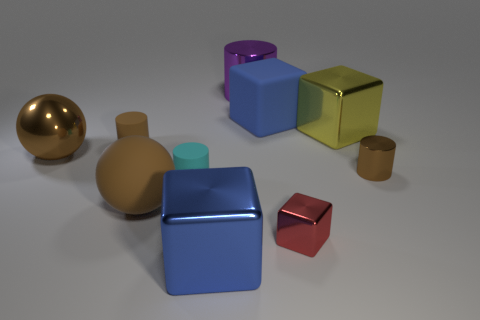Are the tiny cyan cylinder and the sphere behind the big brown matte object made of the same material?
Provide a short and direct response. No. How many objects are purple shiny objects or big purple metallic balls?
Provide a succinct answer. 1. Are any large spheres visible?
Ensure brevity in your answer.  Yes. What is the shape of the tiny object that is in front of the large brown thing that is in front of the large brown metal ball?
Your response must be concise. Cube. How many things are either small cylinders on the left side of the big yellow object or things in front of the small block?
Ensure brevity in your answer.  3. What is the material of the red cube that is the same size as the cyan object?
Your response must be concise. Metal. What is the color of the large metallic cylinder?
Offer a terse response. Purple. What is the material of the large cube that is left of the red shiny block and behind the brown matte cylinder?
Your answer should be compact. Rubber. There is a big blue object on the right side of the large blue cube that is to the left of the large purple metallic thing; is there a big blue cube in front of it?
Provide a succinct answer. Yes. There is a matte cylinder that is the same color as the big rubber sphere; what is its size?
Ensure brevity in your answer.  Small. 